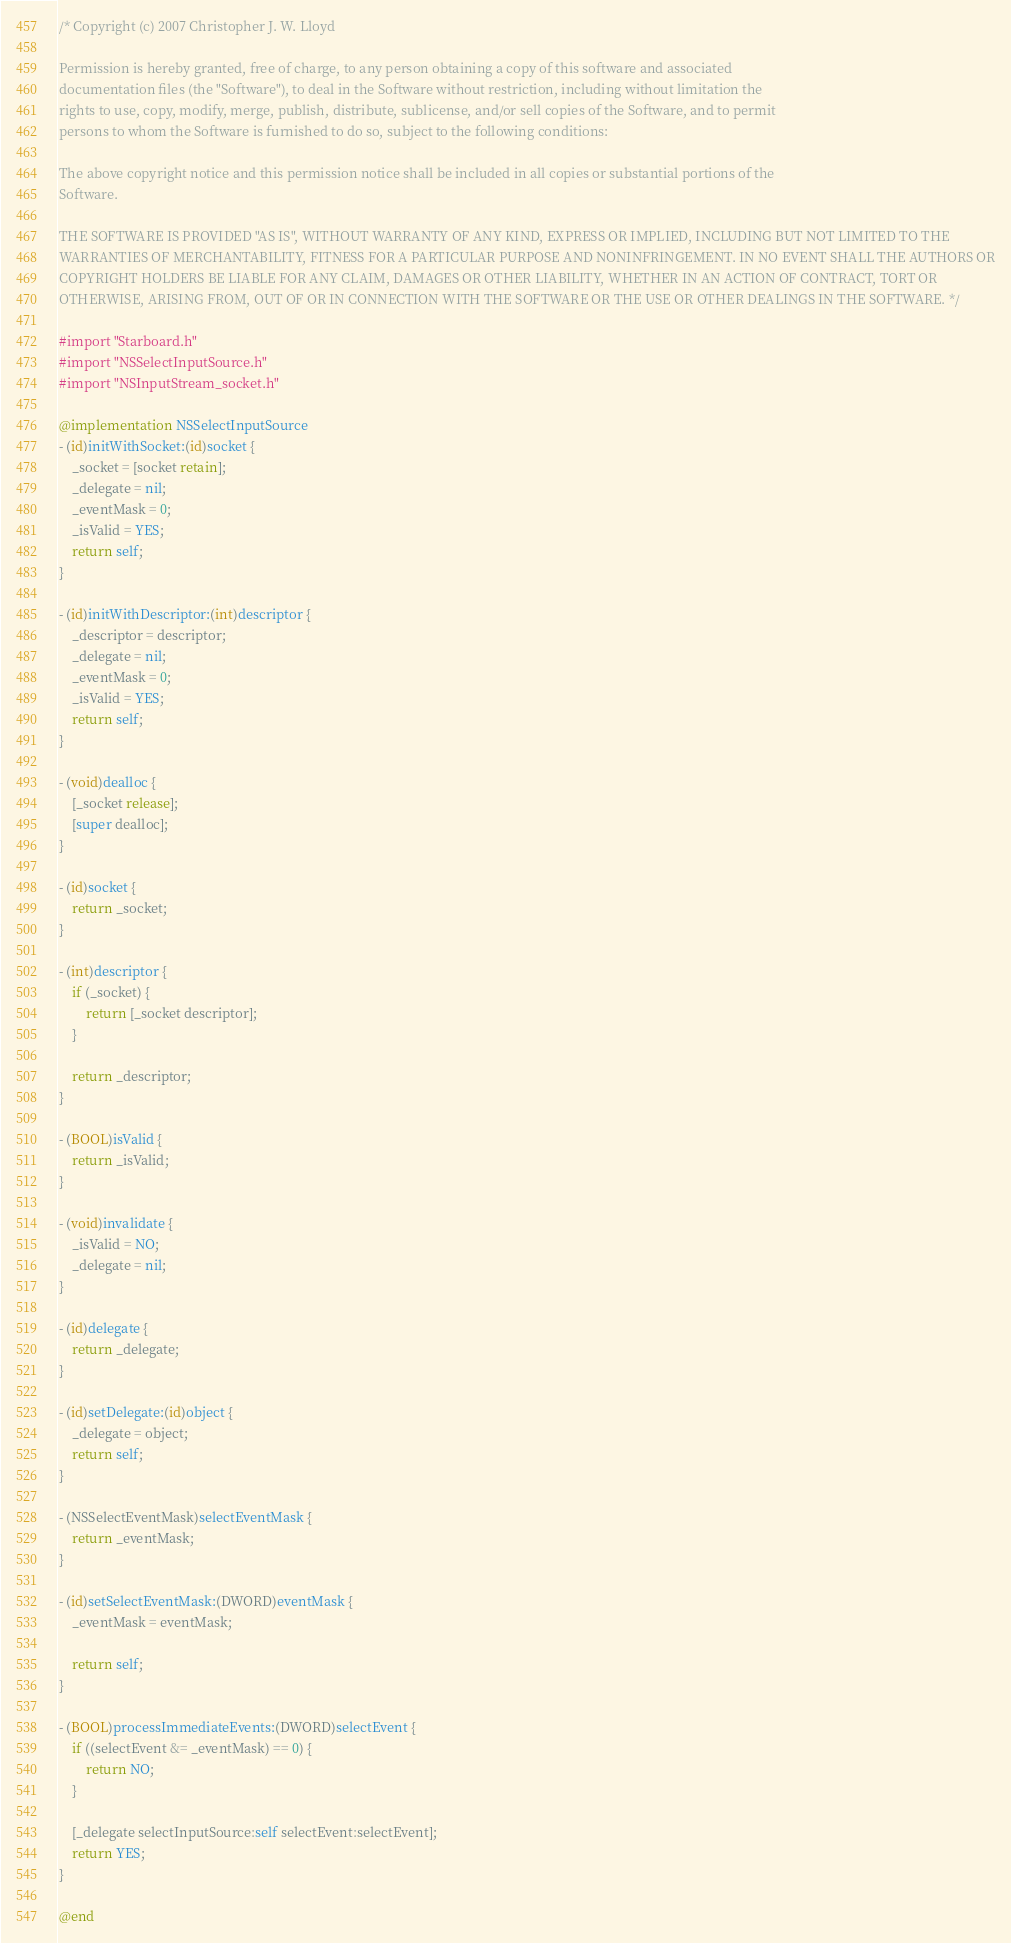Convert code to text. <code><loc_0><loc_0><loc_500><loc_500><_ObjectiveC_>/* Copyright (c) 2007 Christopher J. W. Lloyd

Permission is hereby granted, free of charge, to any person obtaining a copy of this software and associated
documentation files (the "Software"), to deal in the Software without restriction, including without limitation the
rights to use, copy, modify, merge, publish, distribute, sublicense, and/or sell copies of the Software, and to permit
persons to whom the Software is furnished to do so, subject to the following conditions:

The above copyright notice and this permission notice shall be included in all copies or substantial portions of the
Software.

THE SOFTWARE IS PROVIDED "AS IS", WITHOUT WARRANTY OF ANY KIND, EXPRESS OR IMPLIED, INCLUDING BUT NOT LIMITED TO THE
WARRANTIES OF MERCHANTABILITY, FITNESS FOR A PARTICULAR PURPOSE AND NONINFRINGEMENT. IN NO EVENT SHALL THE AUTHORS OR
COPYRIGHT HOLDERS BE LIABLE FOR ANY CLAIM, DAMAGES OR OTHER LIABILITY, WHETHER IN AN ACTION OF CONTRACT, TORT OR
OTHERWISE, ARISING FROM, OUT OF OR IN CONNECTION WITH THE SOFTWARE OR THE USE OR OTHER DEALINGS IN THE SOFTWARE. */

#import "Starboard.h"
#import "NSSelectInputSource.h"
#import "NSInputStream_socket.h"

@implementation NSSelectInputSource
- (id)initWithSocket:(id)socket {
    _socket = [socket retain];
    _delegate = nil;
    _eventMask = 0;
    _isValid = YES;
    return self;
}

- (id)initWithDescriptor:(int)descriptor {
    _descriptor = descriptor;
    _delegate = nil;
    _eventMask = 0;
    _isValid = YES;
    return self;
}

- (void)dealloc {
    [_socket release];
    [super dealloc];
}

- (id)socket {
    return _socket;
}

- (int)descriptor {
    if (_socket) {
        return [_socket descriptor];
    }

    return _descriptor;
}

- (BOOL)isValid {
    return _isValid;
}

- (void)invalidate {
    _isValid = NO;
    _delegate = nil;
}

- (id)delegate {
    return _delegate;
}

- (id)setDelegate:(id)object {
    _delegate = object;
    return self;
}

- (NSSelectEventMask)selectEventMask {
    return _eventMask;
}

- (id)setSelectEventMask:(DWORD)eventMask {
    _eventMask = eventMask;

    return self;
}

- (BOOL)processImmediateEvents:(DWORD)selectEvent {
    if ((selectEvent &= _eventMask) == 0) {
        return NO;
    }

    [_delegate selectInputSource:self selectEvent:selectEvent];
    return YES;
}

@end
</code> 